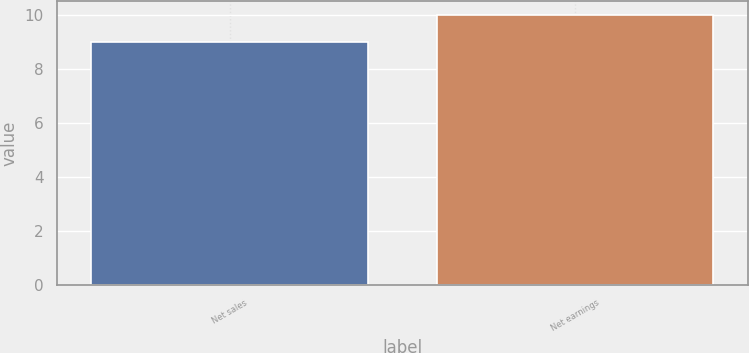<chart> <loc_0><loc_0><loc_500><loc_500><bar_chart><fcel>Net sales<fcel>Net earnings<nl><fcel>9<fcel>10<nl></chart> 